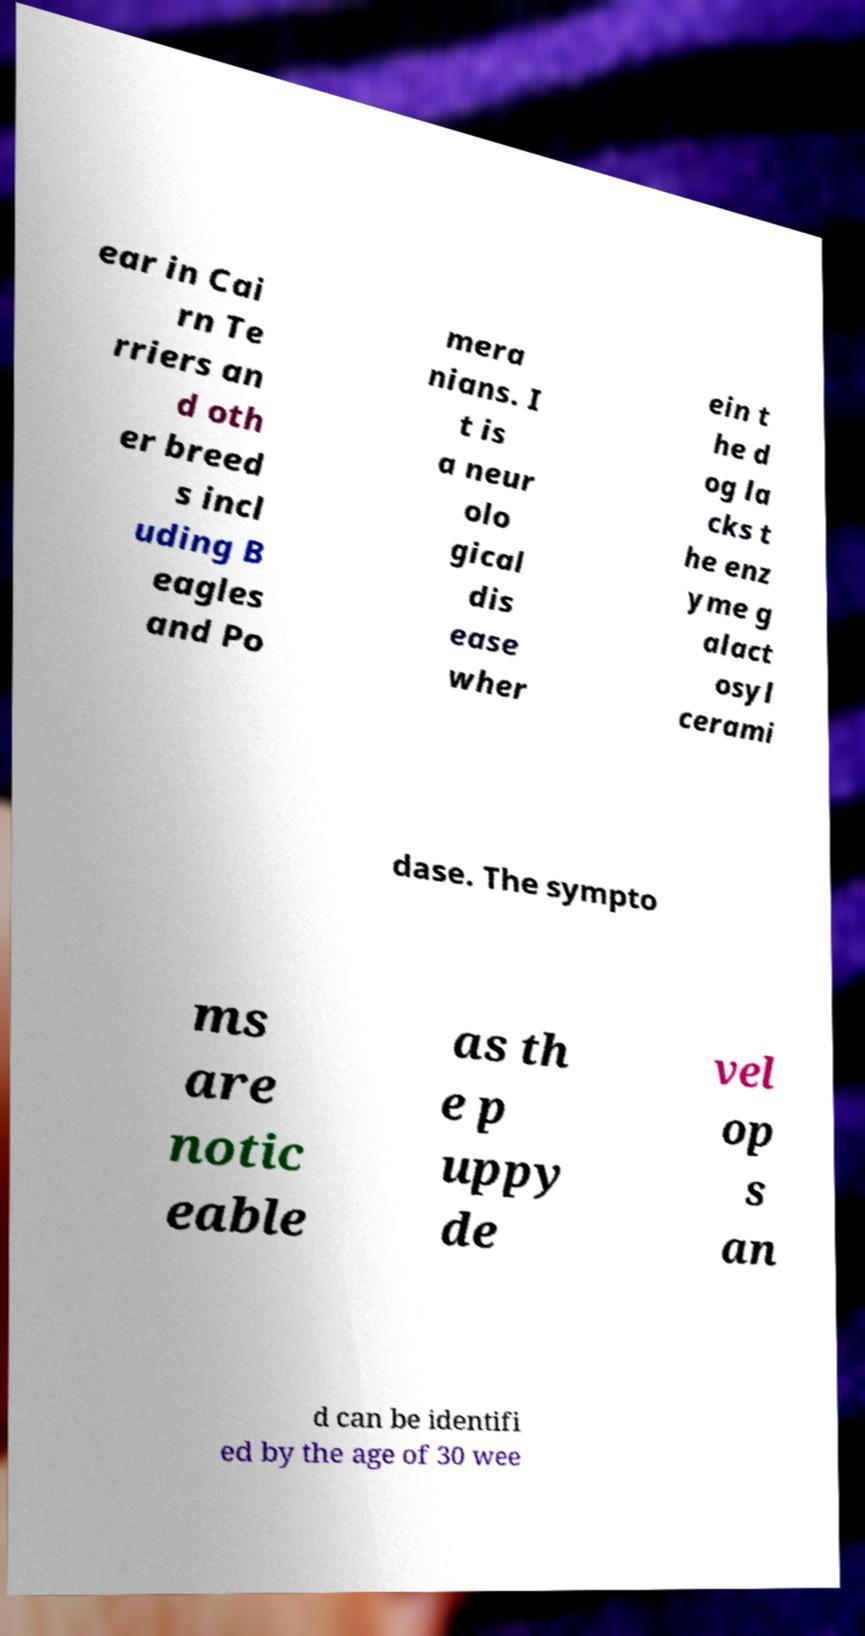Can you read and provide the text displayed in the image?This photo seems to have some interesting text. Can you extract and type it out for me? ear in Cai rn Te rriers an d oth er breed s incl uding B eagles and Po mera nians. I t is a neur olo gical dis ease wher ein t he d og la cks t he enz yme g alact osyl cerami dase. The sympto ms are notic eable as th e p uppy de vel op s an d can be identifi ed by the age of 30 wee 